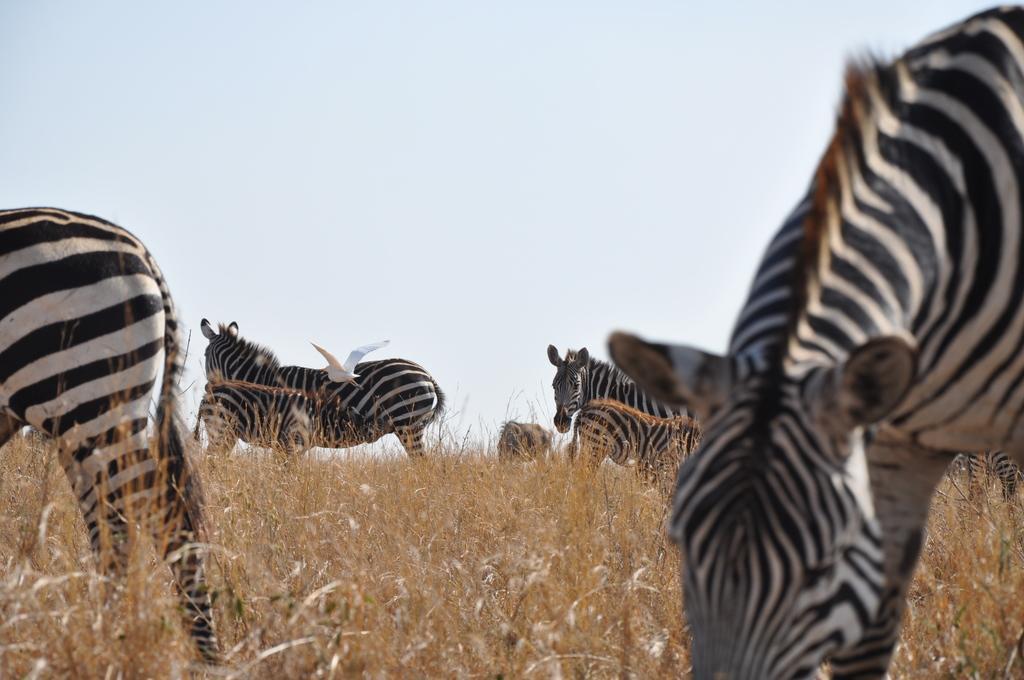How would you summarize this image in a sentence or two? In this image I can see few animals and they are in black and white color and I can see the dried grass and the grass is in brown color. Background I can the bird in white color and the sky is in white color. 